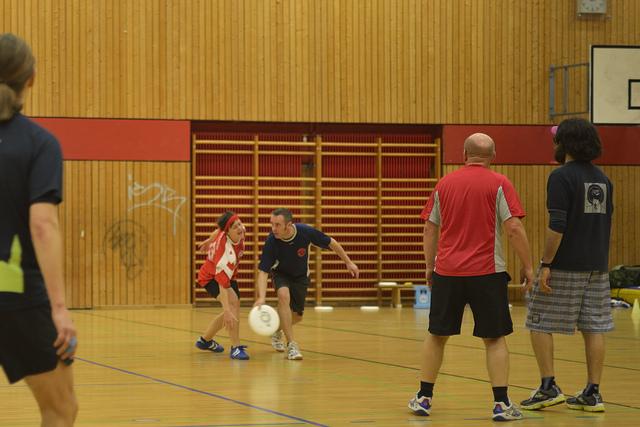Is the artwork on the back wall valuable?
Give a very brief answer. No. What is in the man's hand?
Quick response, please. Frisbee. Is anyone wearing knee pads?
Quick response, please. No. Is the court inner city?
Quick response, please. Yes. How many men are there?
Short answer required. 3. What is the brand name of her shoes?
Concise answer only. Adidas. 